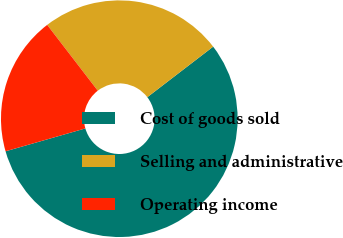<chart> <loc_0><loc_0><loc_500><loc_500><pie_chart><fcel>Cost of goods sold<fcel>Selling and administrative<fcel>Operating income<nl><fcel>55.97%<fcel>25.01%<fcel>19.01%<nl></chart> 